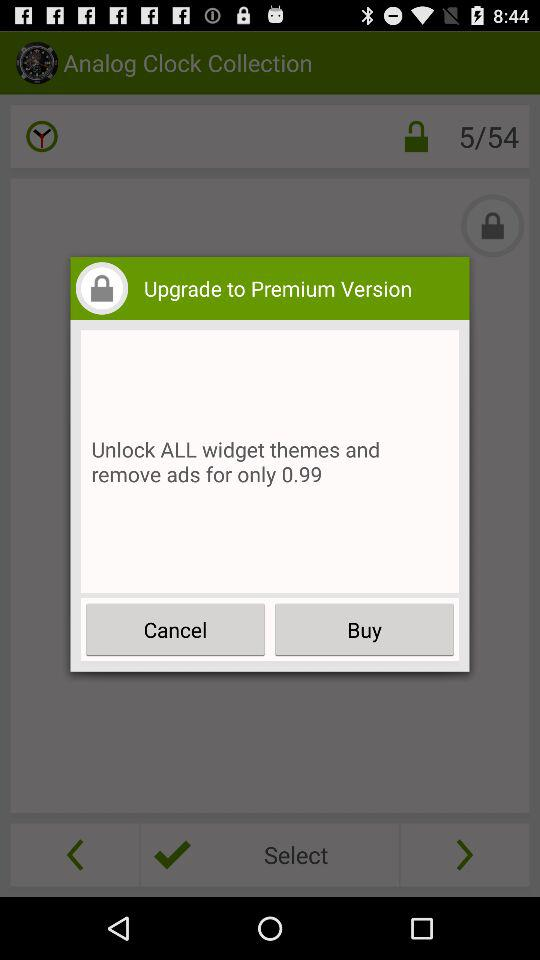How much money is needed to unlock all widget themes and remove ads? The money needed is 0.99. 